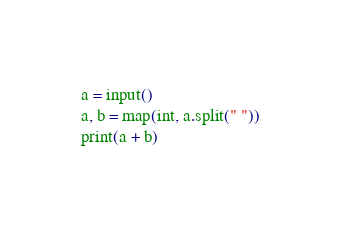Convert code to text. <code><loc_0><loc_0><loc_500><loc_500><_Python_>a = input()
a, b = map(int, a.split(" "))
print(a + b)
</code> 